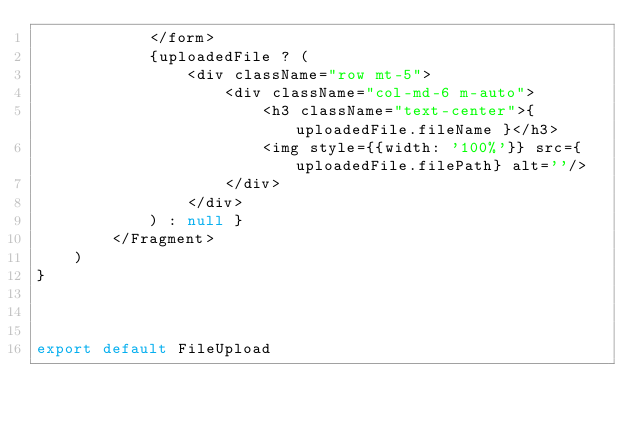Convert code to text. <code><loc_0><loc_0><loc_500><loc_500><_JavaScript_>            </form>
            {uploadedFile ? (
                <div className="row mt-5">
                    <div className="col-md-6 m-auto">
                        <h3 className="text-center">{ uploadedFile.fileName }</h3>
                        <img style={{width: '100%'}} src={uploadedFile.filePath} alt=''/>
                    </div>
                </div>
            ) : null }
        </Fragment>
    )
}



export default FileUpload
</code> 